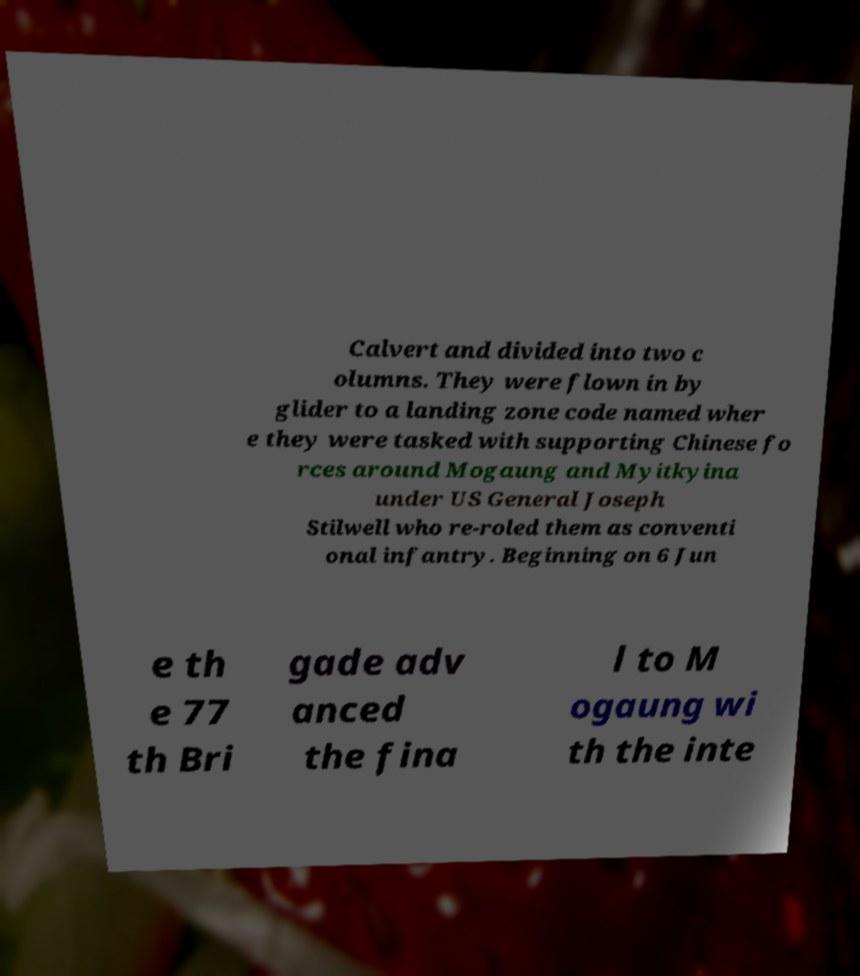Could you assist in decoding the text presented in this image and type it out clearly? Calvert and divided into two c olumns. They were flown in by glider to a landing zone code named wher e they were tasked with supporting Chinese fo rces around Mogaung and Myitkyina under US General Joseph Stilwell who re-roled them as conventi onal infantry. Beginning on 6 Jun e th e 77 th Bri gade adv anced the fina l to M ogaung wi th the inte 